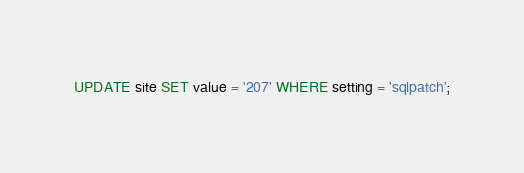Convert code to text. <code><loc_0><loc_0><loc_500><loc_500><_SQL_>UPDATE site SET value = '207' WHERE setting = 'sqlpatch';</code> 